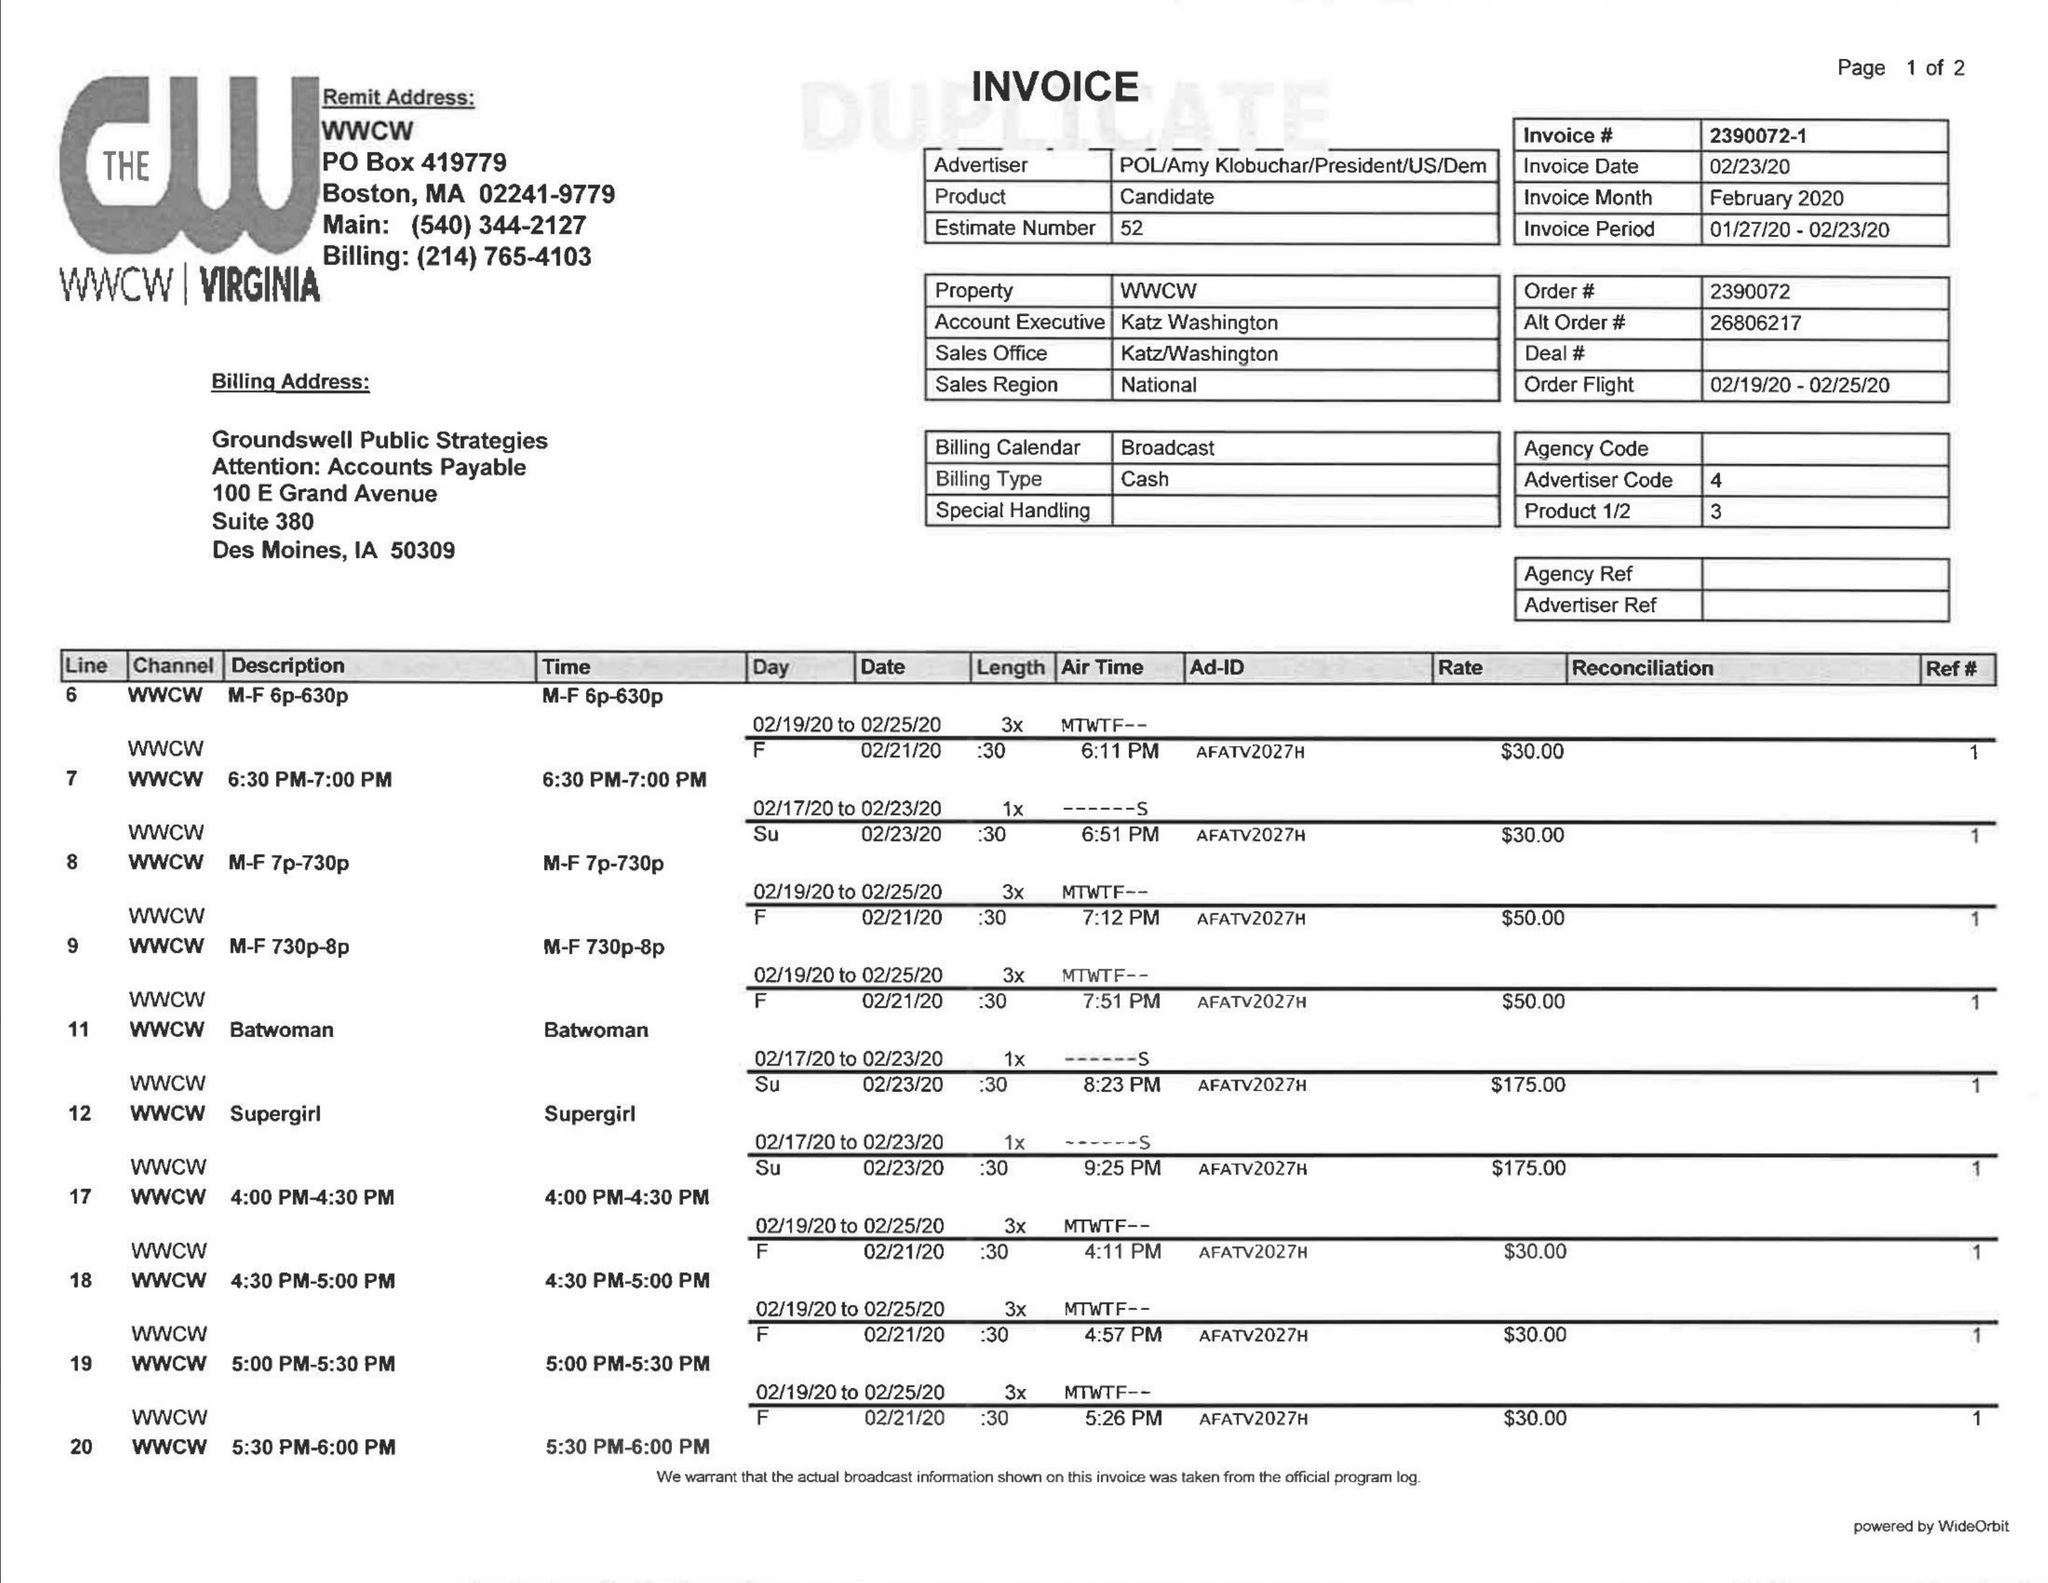What is the value for the flight_from?
Answer the question using a single word or phrase. 02/19/20 